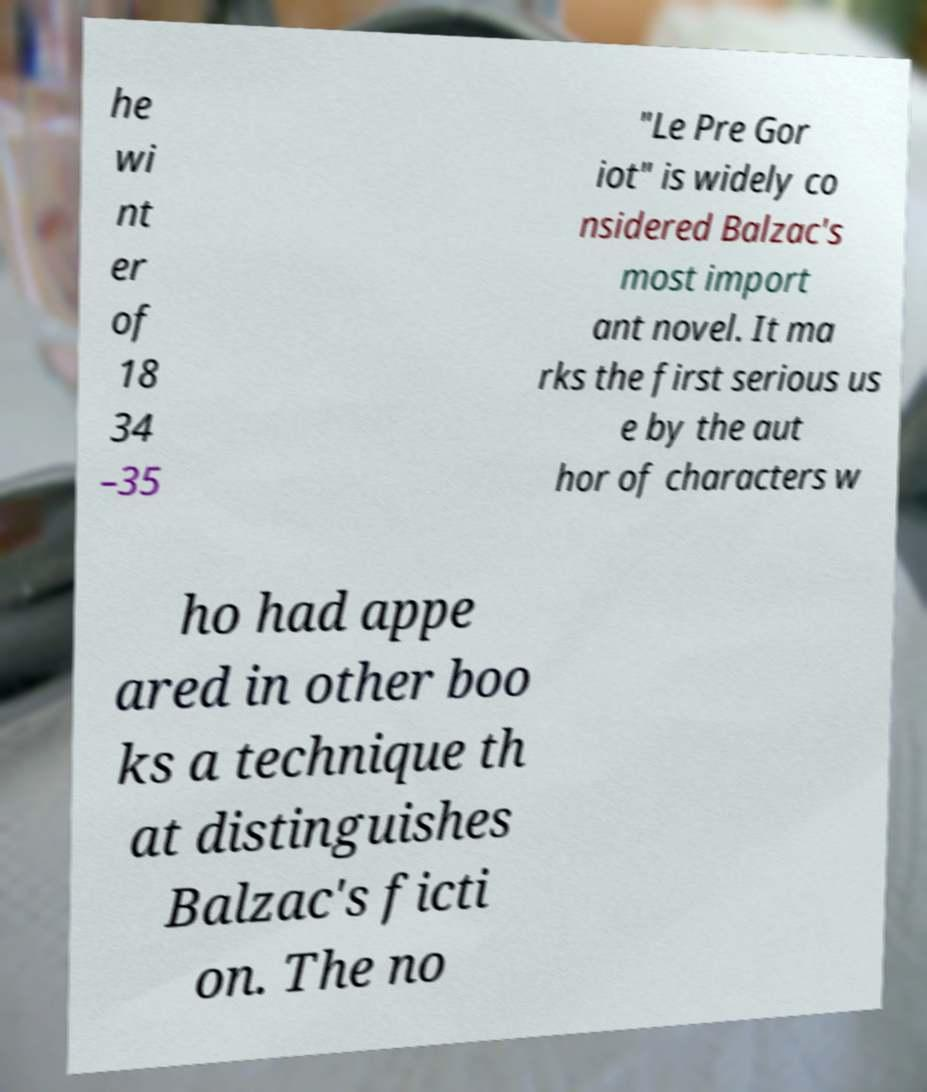Please identify and transcribe the text found in this image. he wi nt er of 18 34 –35 "Le Pre Gor iot" is widely co nsidered Balzac's most import ant novel. It ma rks the first serious us e by the aut hor of characters w ho had appe ared in other boo ks a technique th at distinguishes Balzac's ficti on. The no 